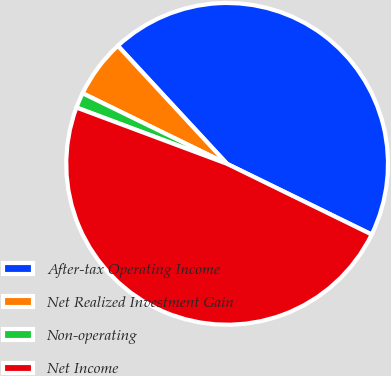Convert chart. <chart><loc_0><loc_0><loc_500><loc_500><pie_chart><fcel>After-tax Operating Income<fcel>Net Realized Investment Gain<fcel>Non-operating<fcel>Net Income<nl><fcel>44.12%<fcel>5.88%<fcel>1.54%<fcel>48.46%<nl></chart> 